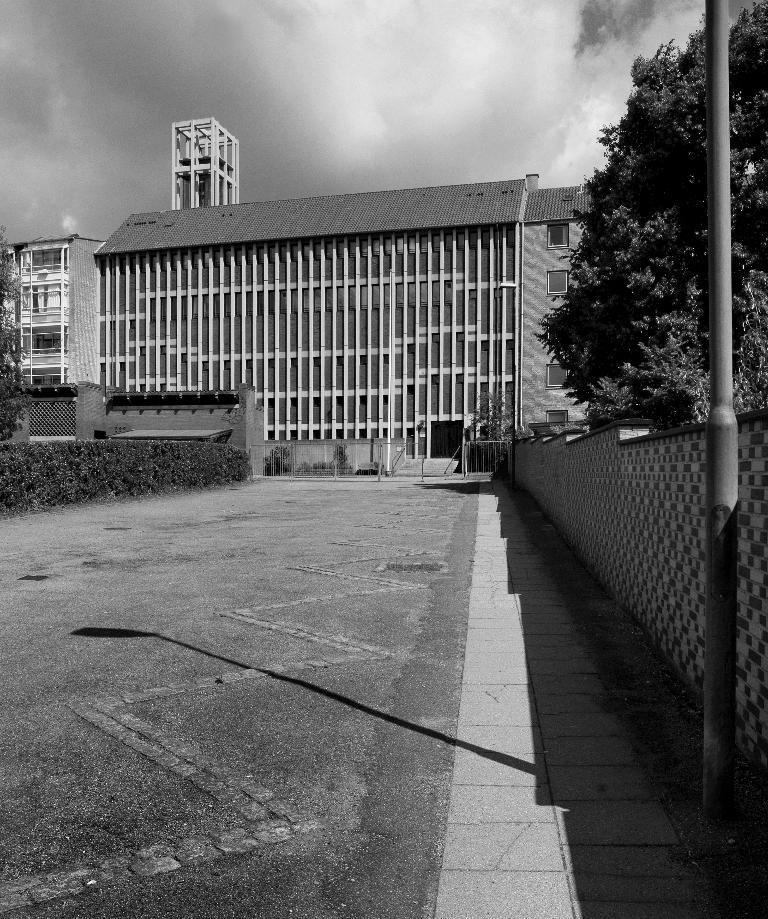Could you give a brief overview of what you see in this image? In this image I can see the road. To the side of the road I can see the wall, pole and many plants. In the background I can see many trees, buildings, clouds and the sky. 